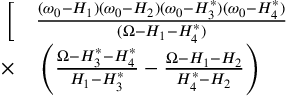<formula> <loc_0><loc_0><loc_500><loc_500>\begin{array} { r l } { \Big [ } & \frac { ( \omega _ { 0 } - H _ { 1 } ) ( \omega _ { 0 } - H _ { 2 } ) ( \omega _ { 0 } - H _ { 3 } ^ { * } ) ( \omega _ { 0 } - H _ { 4 } ^ { * } ) } { ( \Omega - H _ { 1 } - H _ { 4 } ^ { * } ) } } \\ { \times } & \left ( \frac { \Omega - H _ { 3 } ^ { * } - H _ { 4 } ^ { * } } { H _ { 1 } - H _ { 3 } ^ { * } } - \frac { \Omega - H _ { 1 } - H _ { 2 } } { H _ { 4 } ^ { * } - H _ { 2 } } \right ) } \end{array}</formula> 